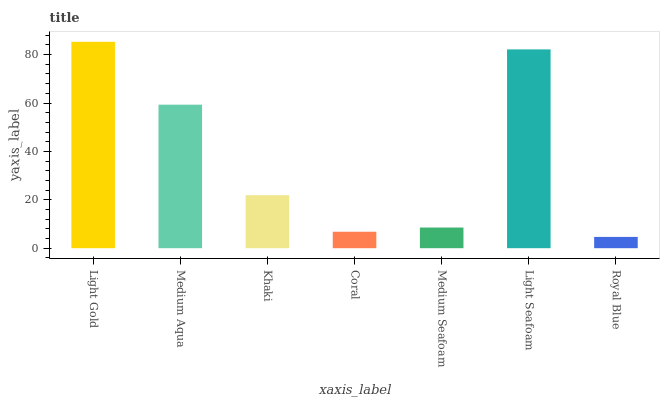Is Royal Blue the minimum?
Answer yes or no. Yes. Is Light Gold the maximum?
Answer yes or no. Yes. Is Medium Aqua the minimum?
Answer yes or no. No. Is Medium Aqua the maximum?
Answer yes or no. No. Is Light Gold greater than Medium Aqua?
Answer yes or no. Yes. Is Medium Aqua less than Light Gold?
Answer yes or no. Yes. Is Medium Aqua greater than Light Gold?
Answer yes or no. No. Is Light Gold less than Medium Aqua?
Answer yes or no. No. Is Khaki the high median?
Answer yes or no. Yes. Is Khaki the low median?
Answer yes or no. Yes. Is Royal Blue the high median?
Answer yes or no. No. Is Light Seafoam the low median?
Answer yes or no. No. 